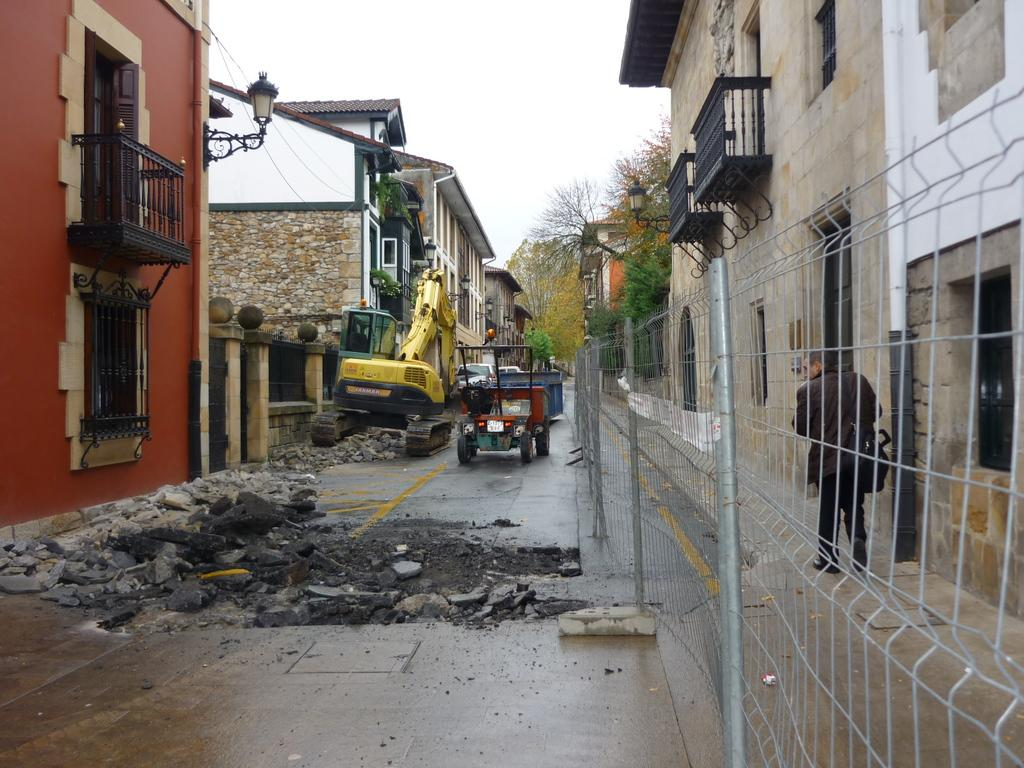What is located in the center of the image? There are vehicles in the center of the image. Where is the man positioned in the image? The man is on the right side of the image. What can be seen in the background of the image? There are buildings, trees, and the sky visible in the background of the image. Can you describe any specific features of the image? Yes, there is a mesh present in the image. What type of jam is being spread on the glass in the image? There is no jam or glass present in the image. What material is the metal object made of in the image? There is no metal object present in the image. 